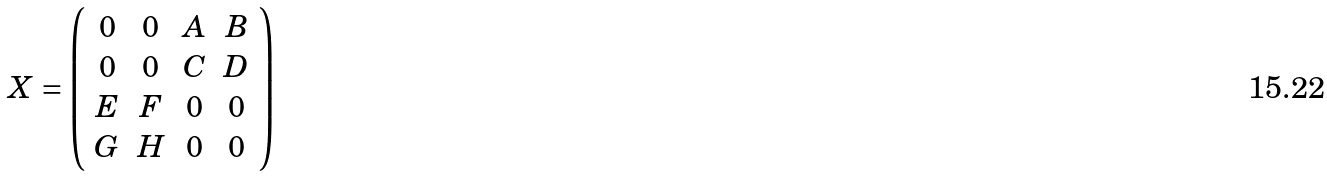Convert formula to latex. <formula><loc_0><loc_0><loc_500><loc_500>X = \left ( \begin{array} { c c c c } 0 & 0 & A & B \\ 0 & 0 & C & D \\ E & F & 0 & 0 \\ G & H & 0 & 0 \end{array} \right )</formula> 